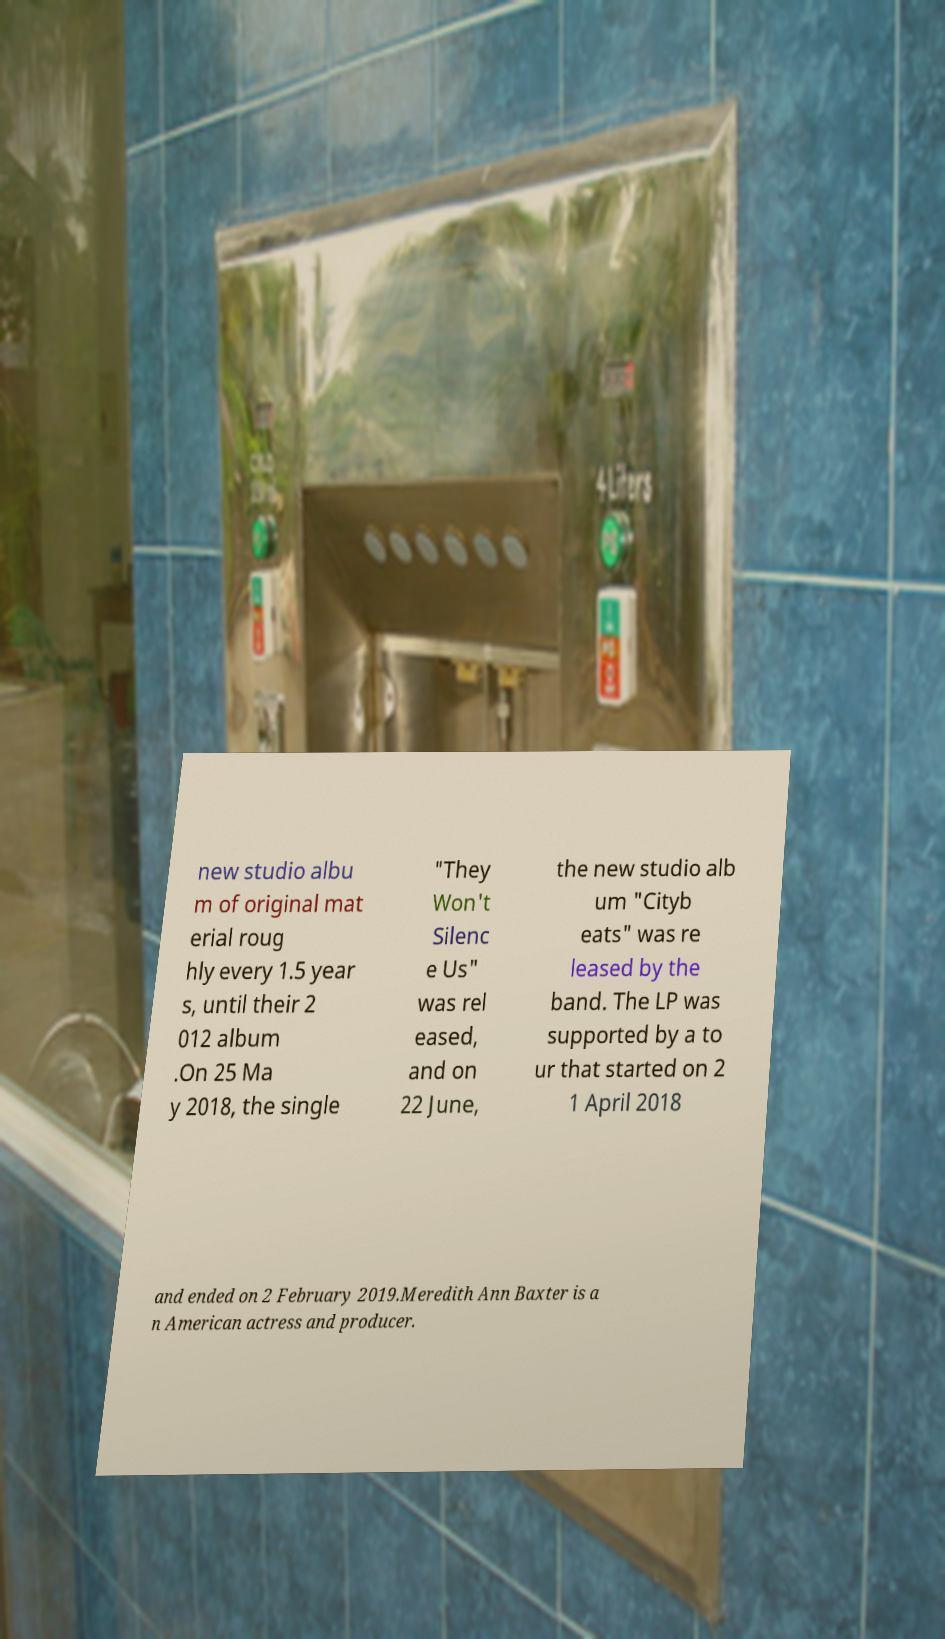For documentation purposes, I need the text within this image transcribed. Could you provide that? new studio albu m of original mat erial roug hly every 1.5 year s, until their 2 012 album .On 25 Ma y 2018, the single "They Won't Silenc e Us" was rel eased, and on 22 June, the new studio alb um "Cityb eats" was re leased by the band. The LP was supported by a to ur that started on 2 1 April 2018 and ended on 2 February 2019.Meredith Ann Baxter is a n American actress and producer. 